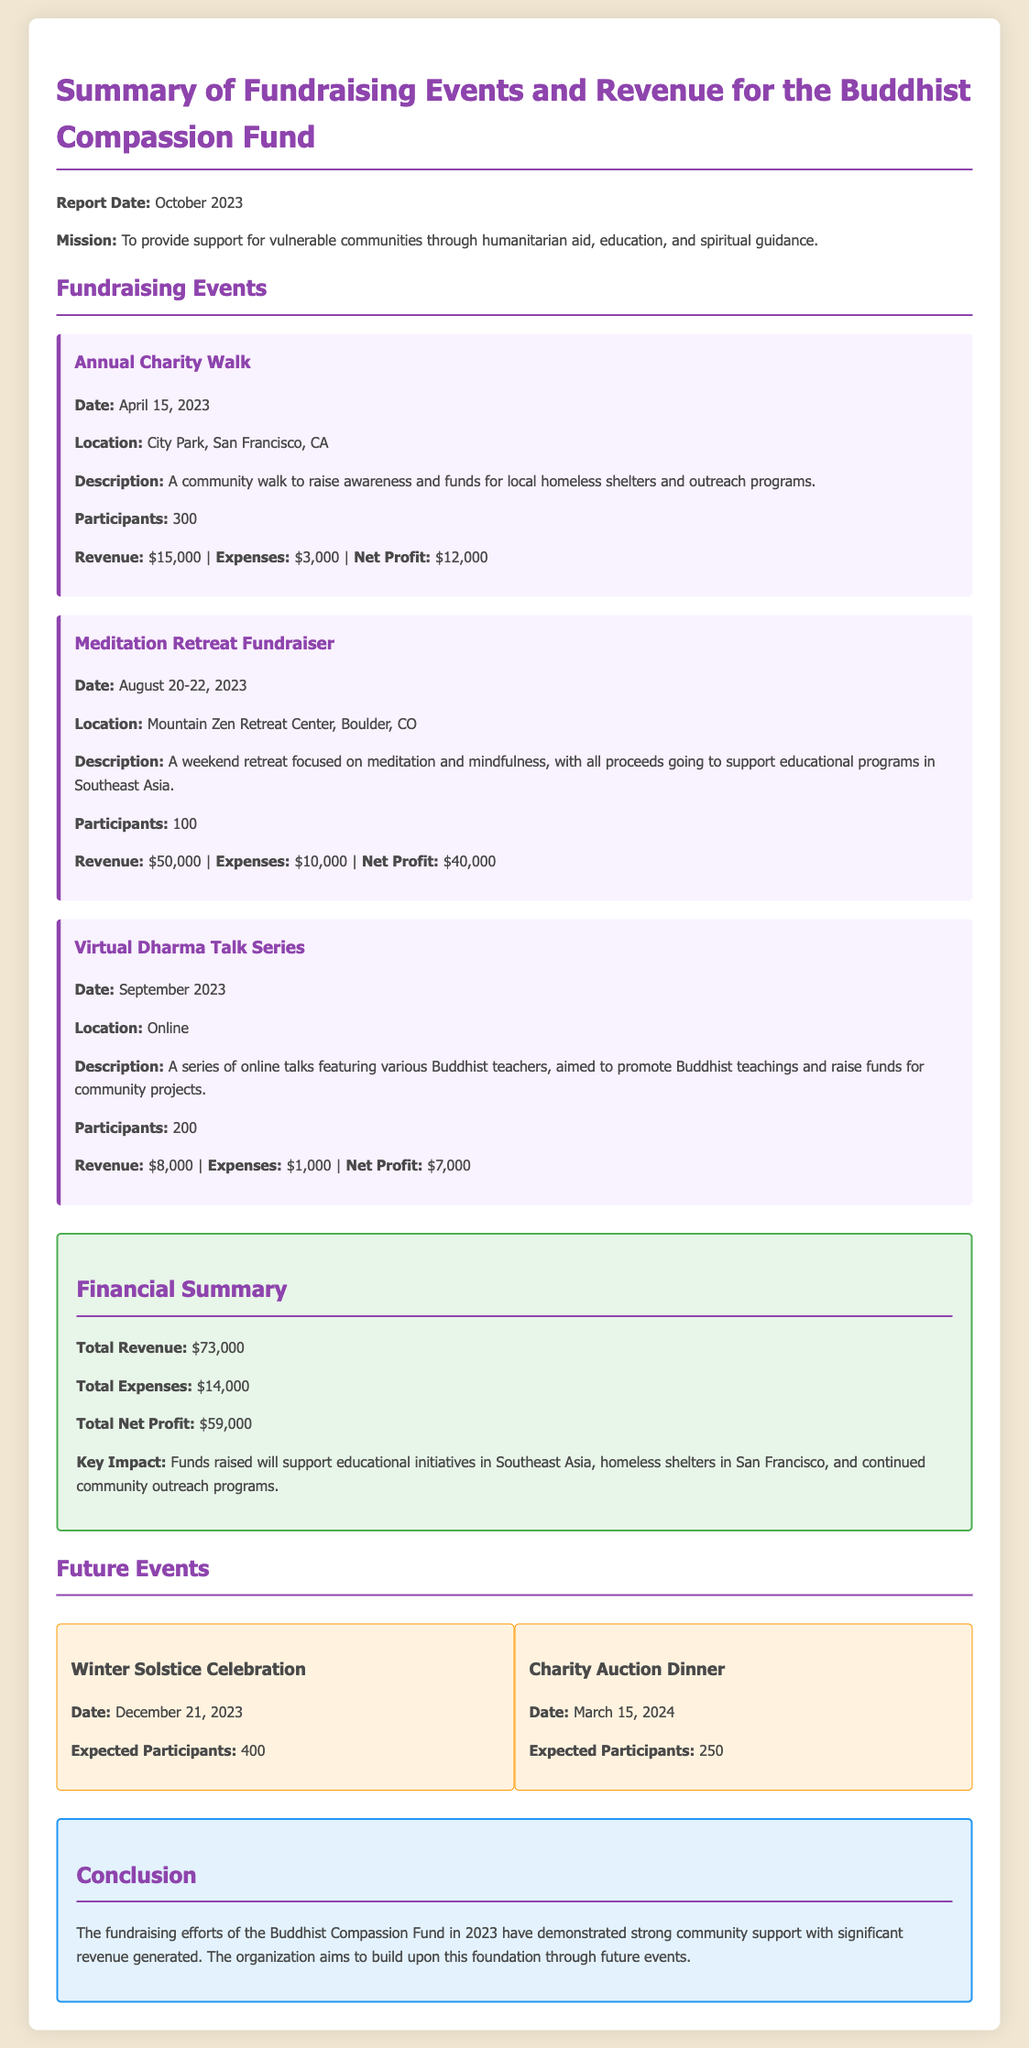what is the mission of the Buddhist Compassion Fund? The mission is to provide support for vulnerable communities through humanitarian aid, education, and spiritual guidance.
Answer: support for vulnerable communities through humanitarian aid, education, and spiritual guidance how much did the Annual Charity Walk raise? The revenue from the Annual Charity Walk is indicated in the document.
Answer: $15,000 what was the net profit from the Meditation Retreat Fundraiser? The net profit is calculated by subtracting expenses from revenue for the Meditation Retreat Fundraiser.
Answer: $40,000 how many participants were at the Virtual Dharma Talk Series? The document provides the number of participants for each event, including the Virtual Dharma Talk Series.
Answer: 200 what is the total net profit for all fundraising events? The total net profit is the sum of the net profits from all the listed events in the document.
Answer: $59,000 what is the location of the Meditation Retreat Fundraiser? The Meditation Retreat Fundraiser’s location can be found in the event details within the document.
Answer: Mountain Zen Retreat Center, Boulder, CO how many expected participants are there for the Winter Solstice Celebration? Expected participants for future events are listed in the document under Future Events.
Answer: 400 what will the funds raised support? The document mentions specific areas where the raised funds will be allocated.
Answer: educational initiatives in Southeast Asia, homeless shelters in San Francisco, and continued community outreach programs what type of event is scheduled for March 15, 2024? Future events are listed in the document, which includes details about their types and dates.
Answer: Charity Auction Dinner 